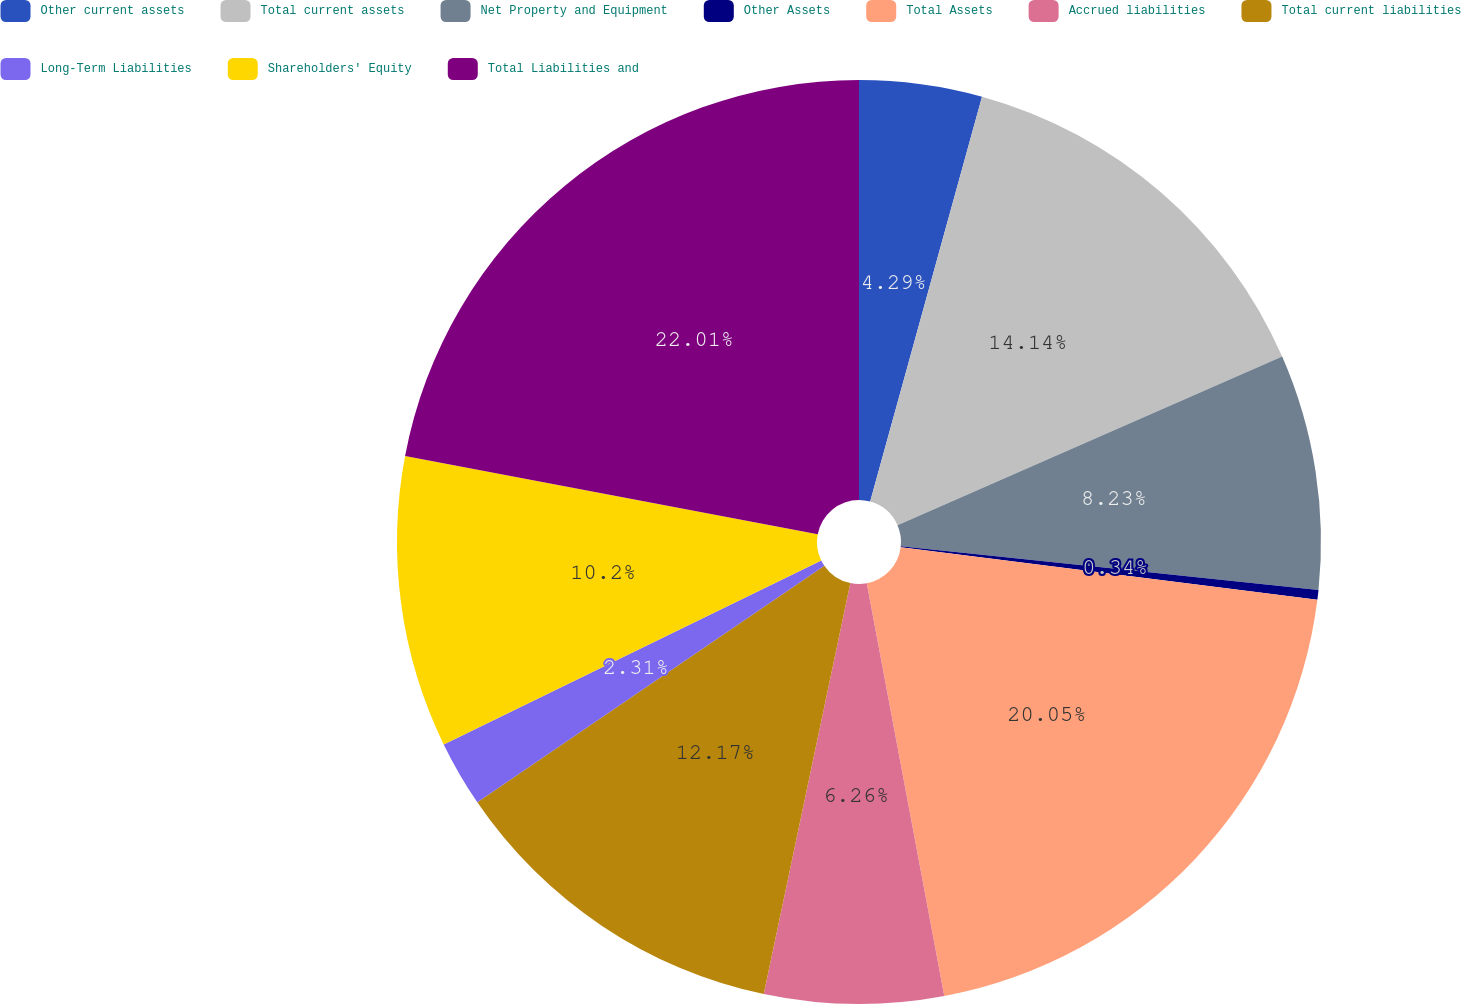Convert chart. <chart><loc_0><loc_0><loc_500><loc_500><pie_chart><fcel>Other current assets<fcel>Total current assets<fcel>Net Property and Equipment<fcel>Other Assets<fcel>Total Assets<fcel>Accrued liabilities<fcel>Total current liabilities<fcel>Long-Term Liabilities<fcel>Shareholders' Equity<fcel>Total Liabilities and<nl><fcel>4.29%<fcel>14.14%<fcel>8.23%<fcel>0.34%<fcel>20.05%<fcel>6.26%<fcel>12.17%<fcel>2.31%<fcel>10.2%<fcel>22.02%<nl></chart> 